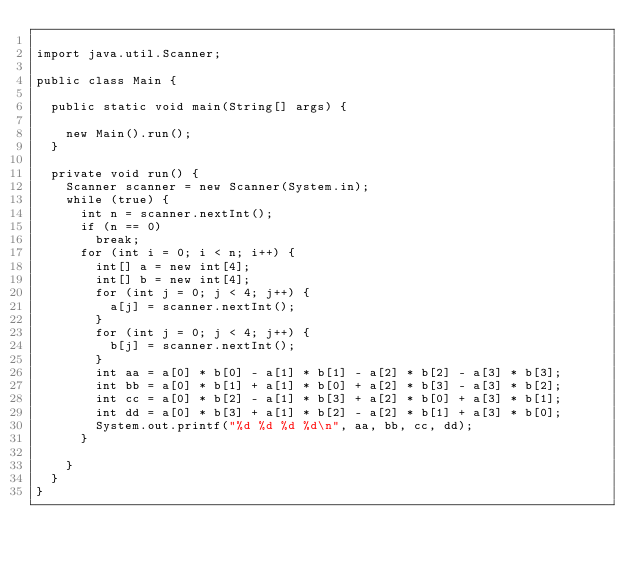<code> <loc_0><loc_0><loc_500><loc_500><_Java_>
import java.util.Scanner;

public class Main {

	public static void main(String[] args) {

		new Main().run();
	}

	private void run() {
		Scanner scanner = new Scanner(System.in);
		while (true) {
			int n = scanner.nextInt();
			if (n == 0)
				break;
			for (int i = 0; i < n; i++) {
				int[] a = new int[4];
				int[] b = new int[4];
				for (int j = 0; j < 4; j++) {
					a[j] = scanner.nextInt();
				}
				for (int j = 0; j < 4; j++) {
					b[j] = scanner.nextInt();
				}
				int aa = a[0] * b[0] - a[1] * b[1] - a[2] * b[2] - a[3] * b[3];
				int bb = a[0] * b[1] + a[1] * b[0] + a[2] * b[3] - a[3] * b[2];
				int cc = a[0] * b[2] - a[1] * b[3] + a[2] * b[0] + a[3] * b[1];
				int dd = a[0] * b[3] + a[1] * b[2] - a[2] * b[1] + a[3] * b[0];
				System.out.printf("%d %d %d %d\n", aa, bb, cc, dd);
			}

		}
	}
}</code> 